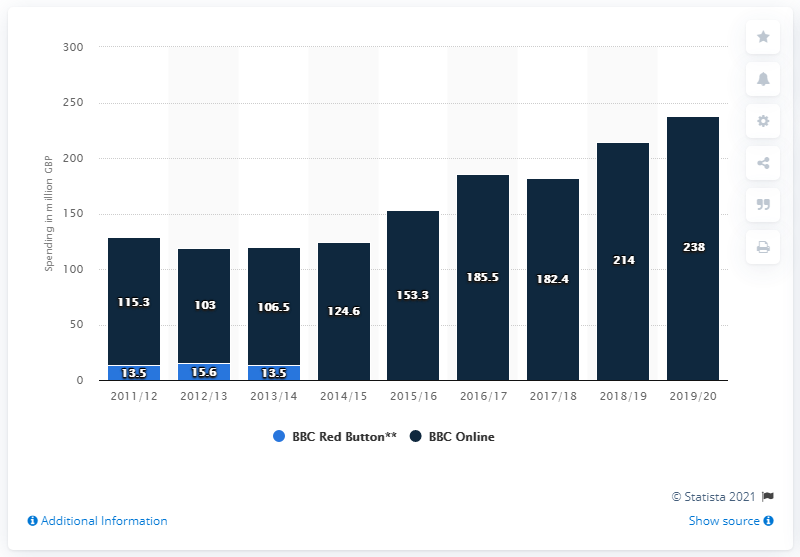Specify some key components in this picture. BBC Online and Red Button spent approximately 238 million pounds in 2019/2020. This statistic displays the BBC's future media spending by medium in the United Kingdom for the year 2019/2020. 